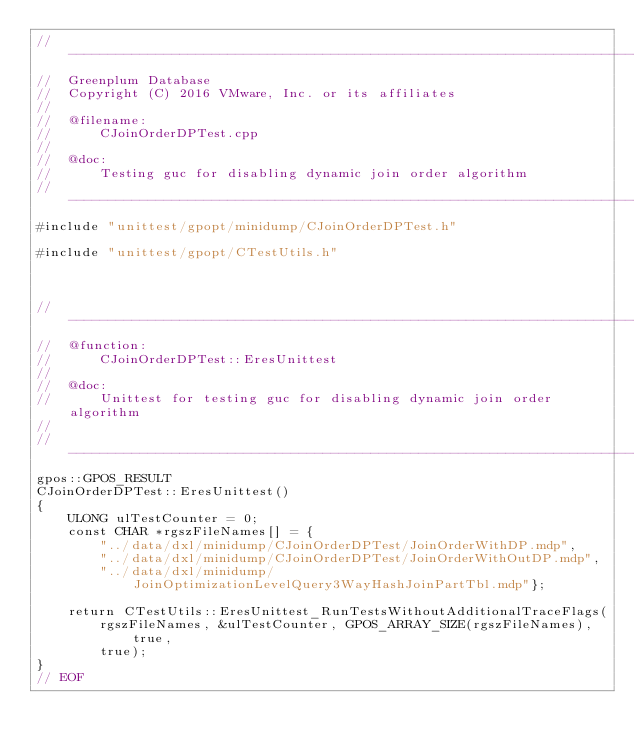<code> <loc_0><loc_0><loc_500><loc_500><_C++_>//---------------------------------------------------------------------------
//	Greenplum Database
//	Copyright (C) 2016 VMware, Inc. or its affiliates
//
//	@filename:
//		CJoinOrderDPTest.cpp
//
//	@doc:
//		Testing guc for disabling dynamic join order algorithm
//---------------------------------------------------------------------------
#include "unittest/gpopt/minidump/CJoinOrderDPTest.h"

#include "unittest/gpopt/CTestUtils.h"



//---------------------------------------------------------------------------
//	@function:
//		CJoinOrderDPTest::EresUnittest
//
//	@doc:
//		Unittest for testing guc for disabling dynamic join order algorithm
//
//---------------------------------------------------------------------------
gpos::GPOS_RESULT
CJoinOrderDPTest::EresUnittest()
{
	ULONG ulTestCounter = 0;
	const CHAR *rgszFileNames[] = {
		"../data/dxl/minidump/CJoinOrderDPTest/JoinOrderWithDP.mdp",
		"../data/dxl/minidump/CJoinOrderDPTest/JoinOrderWithOutDP.mdp",
		"../data/dxl/minidump/JoinOptimizationLevelQuery3WayHashJoinPartTbl.mdp"};

	return CTestUtils::EresUnittest_RunTestsWithoutAdditionalTraceFlags(
		rgszFileNames, &ulTestCounter, GPOS_ARRAY_SIZE(rgszFileNames), true,
		true);
}
// EOF
</code> 